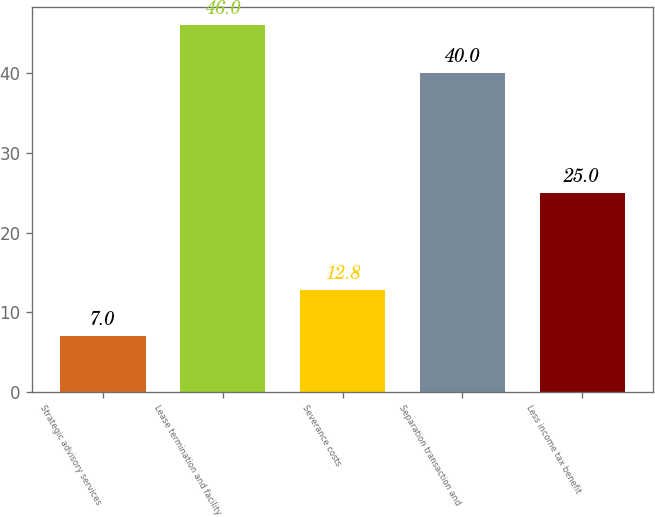Convert chart. <chart><loc_0><loc_0><loc_500><loc_500><bar_chart><fcel>Strategic advisory services<fcel>Lease termination and facility<fcel>Severance costs<fcel>Separation transaction and<fcel>Less income tax benefit<nl><fcel>7<fcel>46<fcel>12.8<fcel>40<fcel>25<nl></chart> 